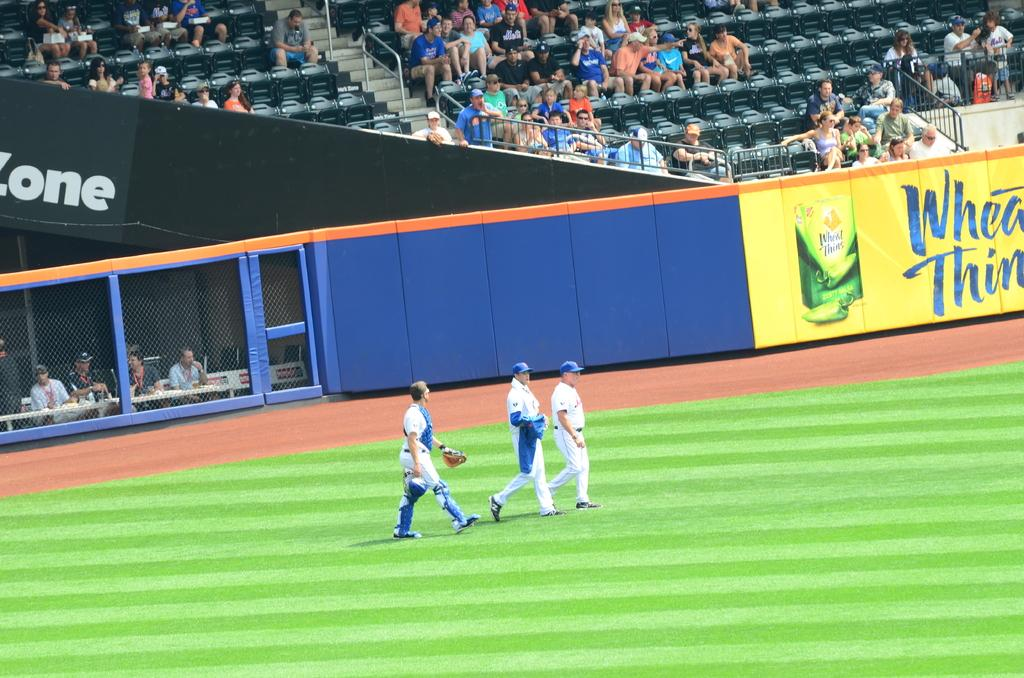<image>
Write a terse but informative summary of the picture. thee players walk on the field with a wheat thins ad next to them 